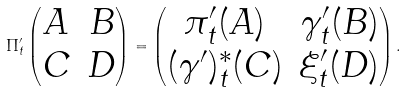Convert formula to latex. <formula><loc_0><loc_0><loc_500><loc_500>\Pi _ { t } ^ { \prime } \begin{pmatrix} A & B \\ C & D \end{pmatrix} = \begin{pmatrix} \pi _ { t } ^ { \prime } ( A ) & \gamma ^ { \prime } _ { t } ( B ) \\ ( \gamma ^ { \prime } ) _ { t } ^ { * } ( C ) & \xi _ { t } ^ { \prime } ( D ) \end{pmatrix} .</formula> 